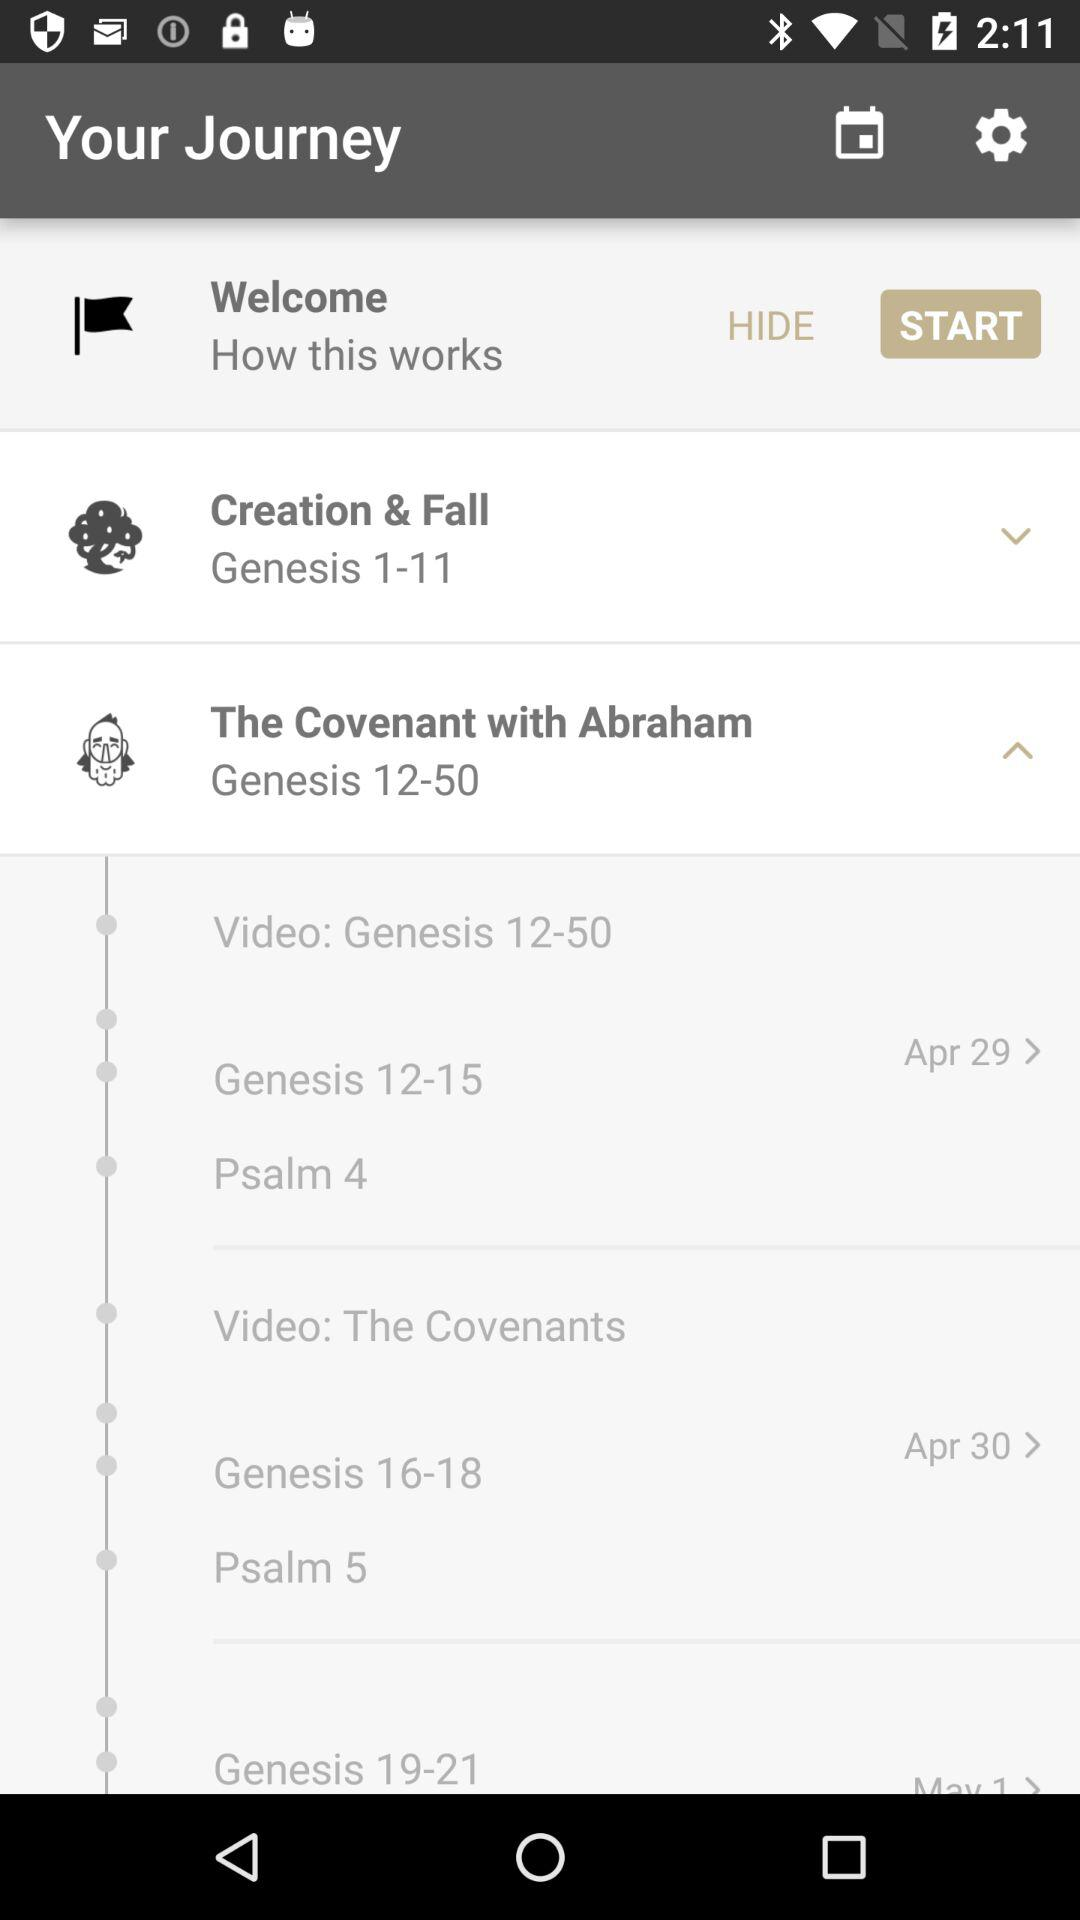How many days long is the journey?
When the provided information is insufficient, respond with <no answer>. <no answer> 